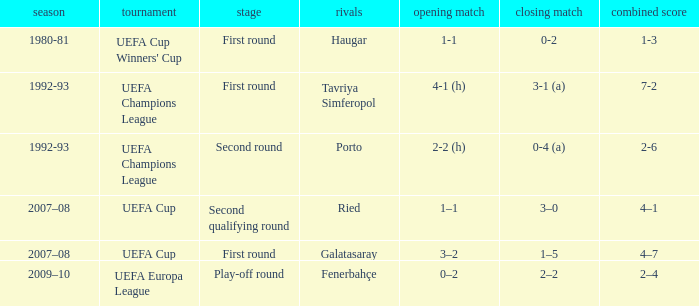What is the total number of round where opponents is haugar 1.0. 